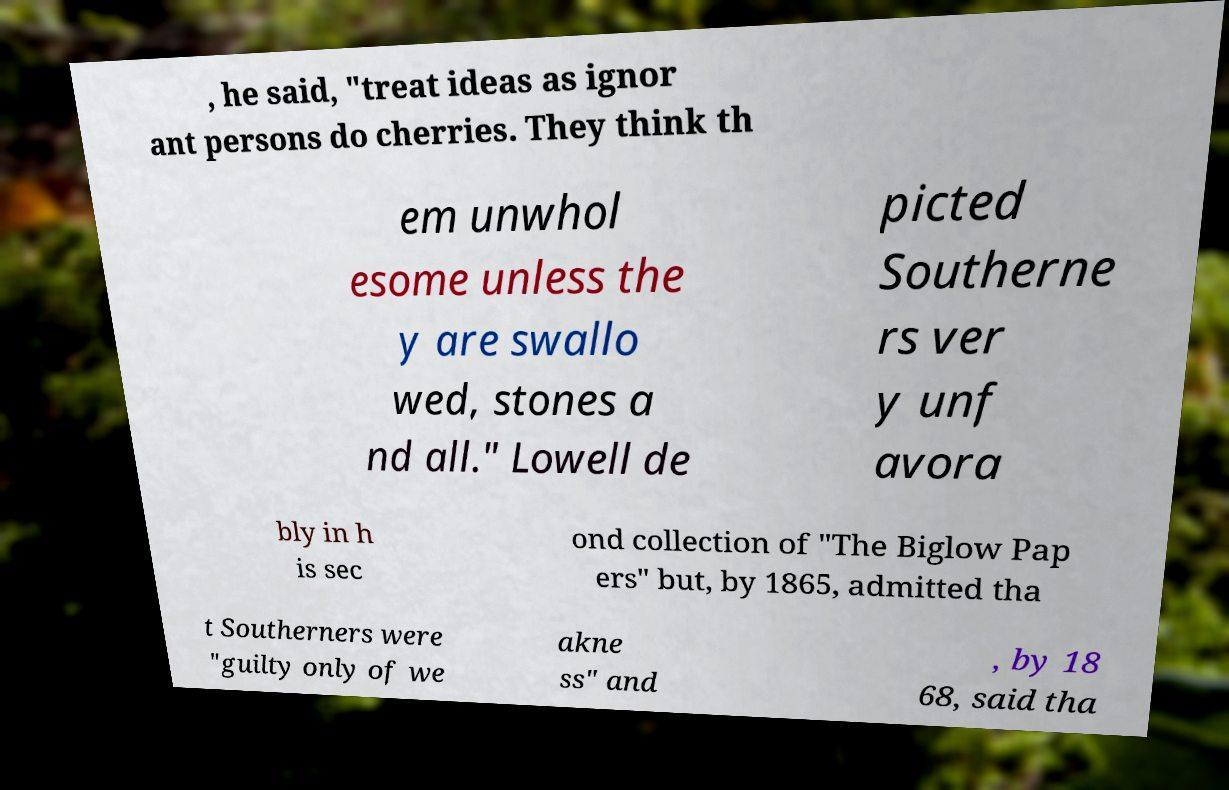Please read and relay the text visible in this image. What does it say? , he said, "treat ideas as ignor ant persons do cherries. They think th em unwhol esome unless the y are swallo wed, stones a nd all." Lowell de picted Southerne rs ver y unf avora bly in h is sec ond collection of "The Biglow Pap ers" but, by 1865, admitted tha t Southerners were "guilty only of we akne ss" and , by 18 68, said tha 